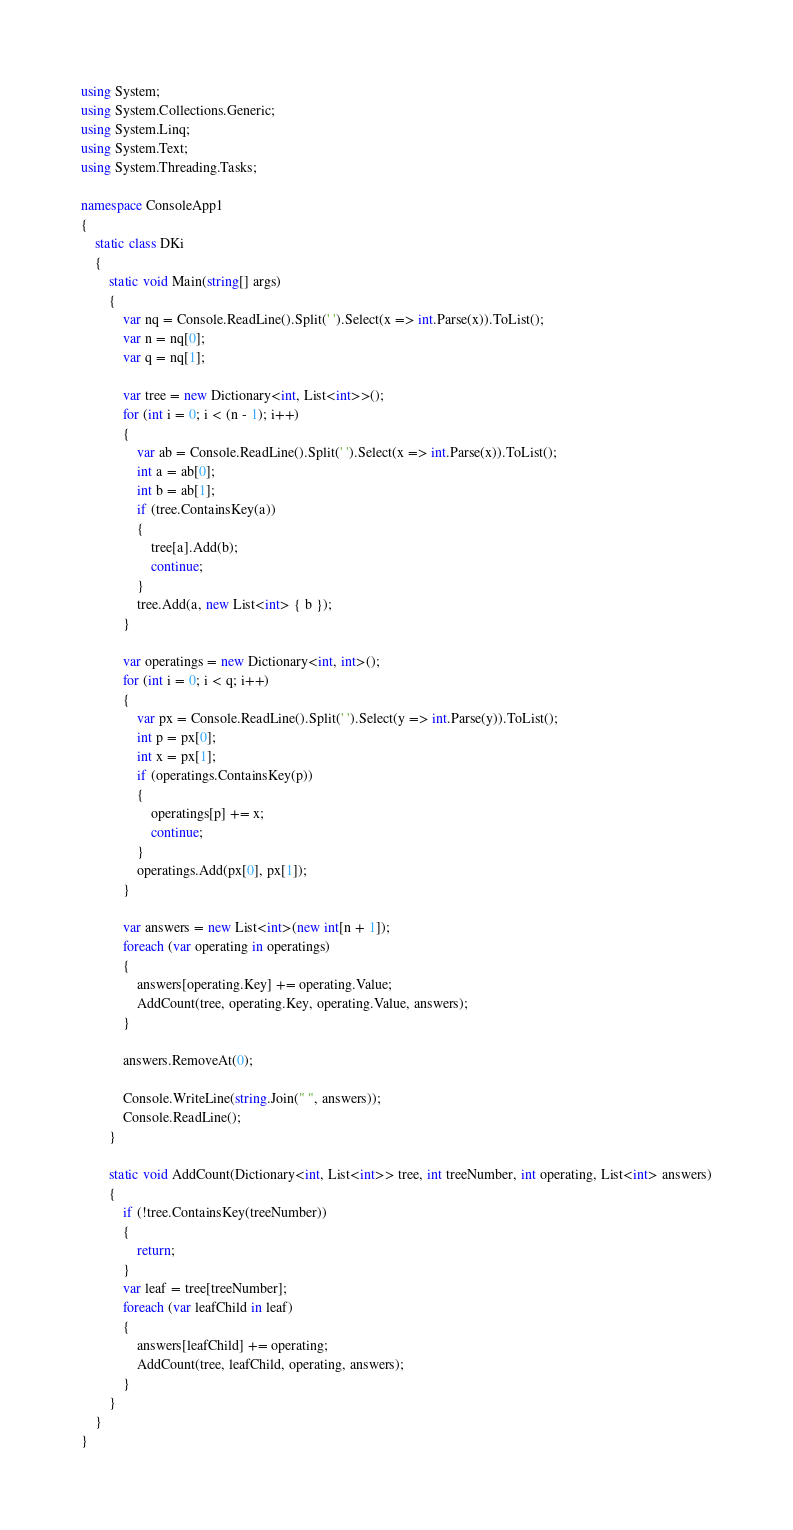Convert code to text. <code><loc_0><loc_0><loc_500><loc_500><_C#_>using System;
using System.Collections.Generic;
using System.Linq;
using System.Text;
using System.Threading.Tasks;

namespace ConsoleApp1
{
    static class DKi
    {
        static void Main(string[] args)
        {
            var nq = Console.ReadLine().Split(' ').Select(x => int.Parse(x)).ToList();
            var n = nq[0];
            var q = nq[1];

            var tree = new Dictionary<int, List<int>>();
            for (int i = 0; i < (n - 1); i++)
            {
                var ab = Console.ReadLine().Split(' ').Select(x => int.Parse(x)).ToList();
                int a = ab[0];
                int b = ab[1];
                if (tree.ContainsKey(a))
                {
                    tree[a].Add(b);
                    continue;
                }
                tree.Add(a, new List<int> { b });
            }

            var operatings = new Dictionary<int, int>(); 
            for (int i = 0; i < q; i++)
            {
                var px = Console.ReadLine().Split(' ').Select(y => int.Parse(y)).ToList();
                int p = px[0];
                int x = px[1];
                if (operatings.ContainsKey(p))
                {
                    operatings[p] += x;
                    continue;
                }
                operatings.Add(px[0], px[1]);
            }

            var answers = new List<int>(new int[n + 1]);
            foreach (var operating in operatings)
            {
                answers[operating.Key] += operating.Value;
                AddCount(tree, operating.Key, operating.Value, answers);
            }

            answers.RemoveAt(0);

            Console.WriteLine(string.Join(" ", answers));
            Console.ReadLine();
        }

        static void AddCount(Dictionary<int, List<int>> tree, int treeNumber, int operating, List<int> answers)
        {
            if (!tree.ContainsKey(treeNumber))
            {
                return;
            }            
            var leaf = tree[treeNumber];
            foreach (var leafChild in leaf)
            {
                answers[leafChild] += operating;
                AddCount(tree, leafChild, operating, answers);
            }            
        }
    }
}</code> 